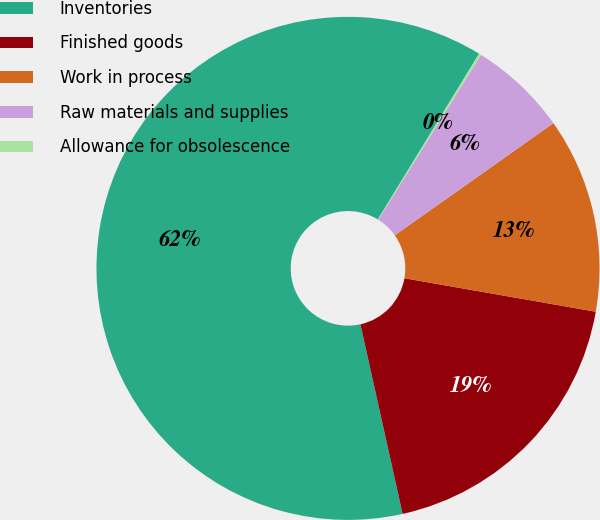Convert chart to OTSL. <chart><loc_0><loc_0><loc_500><loc_500><pie_chart><fcel>Inventories<fcel>Finished goods<fcel>Work in process<fcel>Raw materials and supplies<fcel>Allowance for obsolescence<nl><fcel>62.21%<fcel>18.76%<fcel>12.55%<fcel>6.34%<fcel>0.14%<nl></chart> 